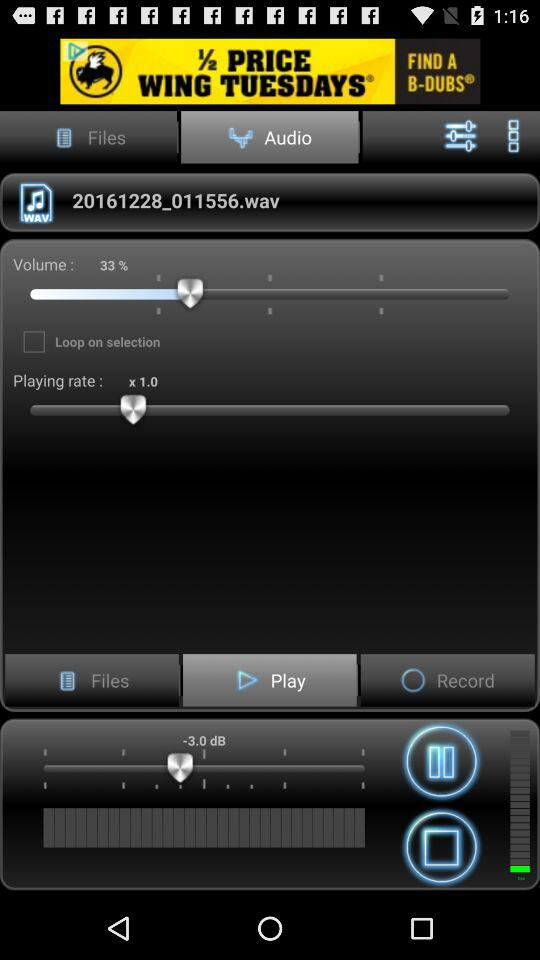What is the volume of the audio file?
Answer the question using a single word or phrase. 33% 